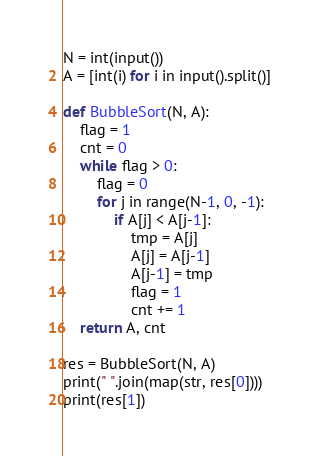Convert code to text. <code><loc_0><loc_0><loc_500><loc_500><_Python_>N = int(input())
A = [int(i) for i in input().split()]

def BubbleSort(N, A):
    flag = 1
    cnt = 0
    while flag > 0:
        flag = 0
        for j in range(N-1, 0, -1):
            if A[j] < A[j-1]:
                tmp = A[j]
                A[j] = A[j-1]
                A[j-1] = tmp
                flag = 1
                cnt += 1
    return A, cnt

res = BubbleSort(N, A)
print(" ".join(map(str, res[0])))
print(res[1])</code> 